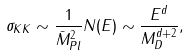<formula> <loc_0><loc_0><loc_500><loc_500>\sigma _ { K K } \sim \frac { 1 } { { \bar { M } } _ { P l } ^ { 2 } } N ( E ) \sim \frac { E ^ { d } } { M _ { D } ^ { d + 2 } } ,</formula> 